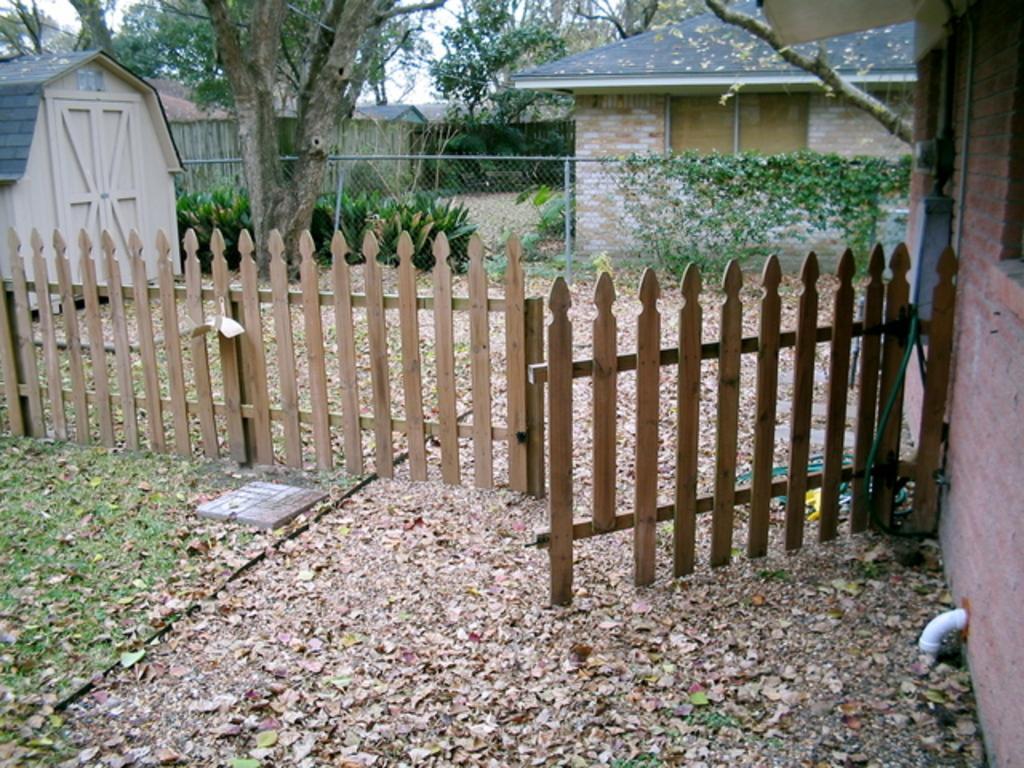Could you give a brief overview of what you see in this image? In this image at front there is a gate. At the back side there are houses, trees. In front of the house fencing was done. 